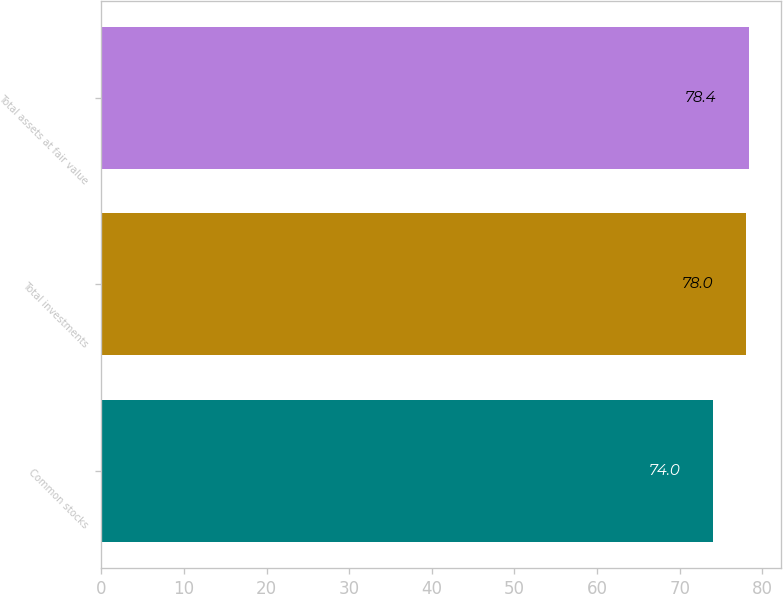Convert chart. <chart><loc_0><loc_0><loc_500><loc_500><bar_chart><fcel>Common stocks<fcel>Total investments<fcel>Total assets at fair value<nl><fcel>74<fcel>78<fcel>78.4<nl></chart> 